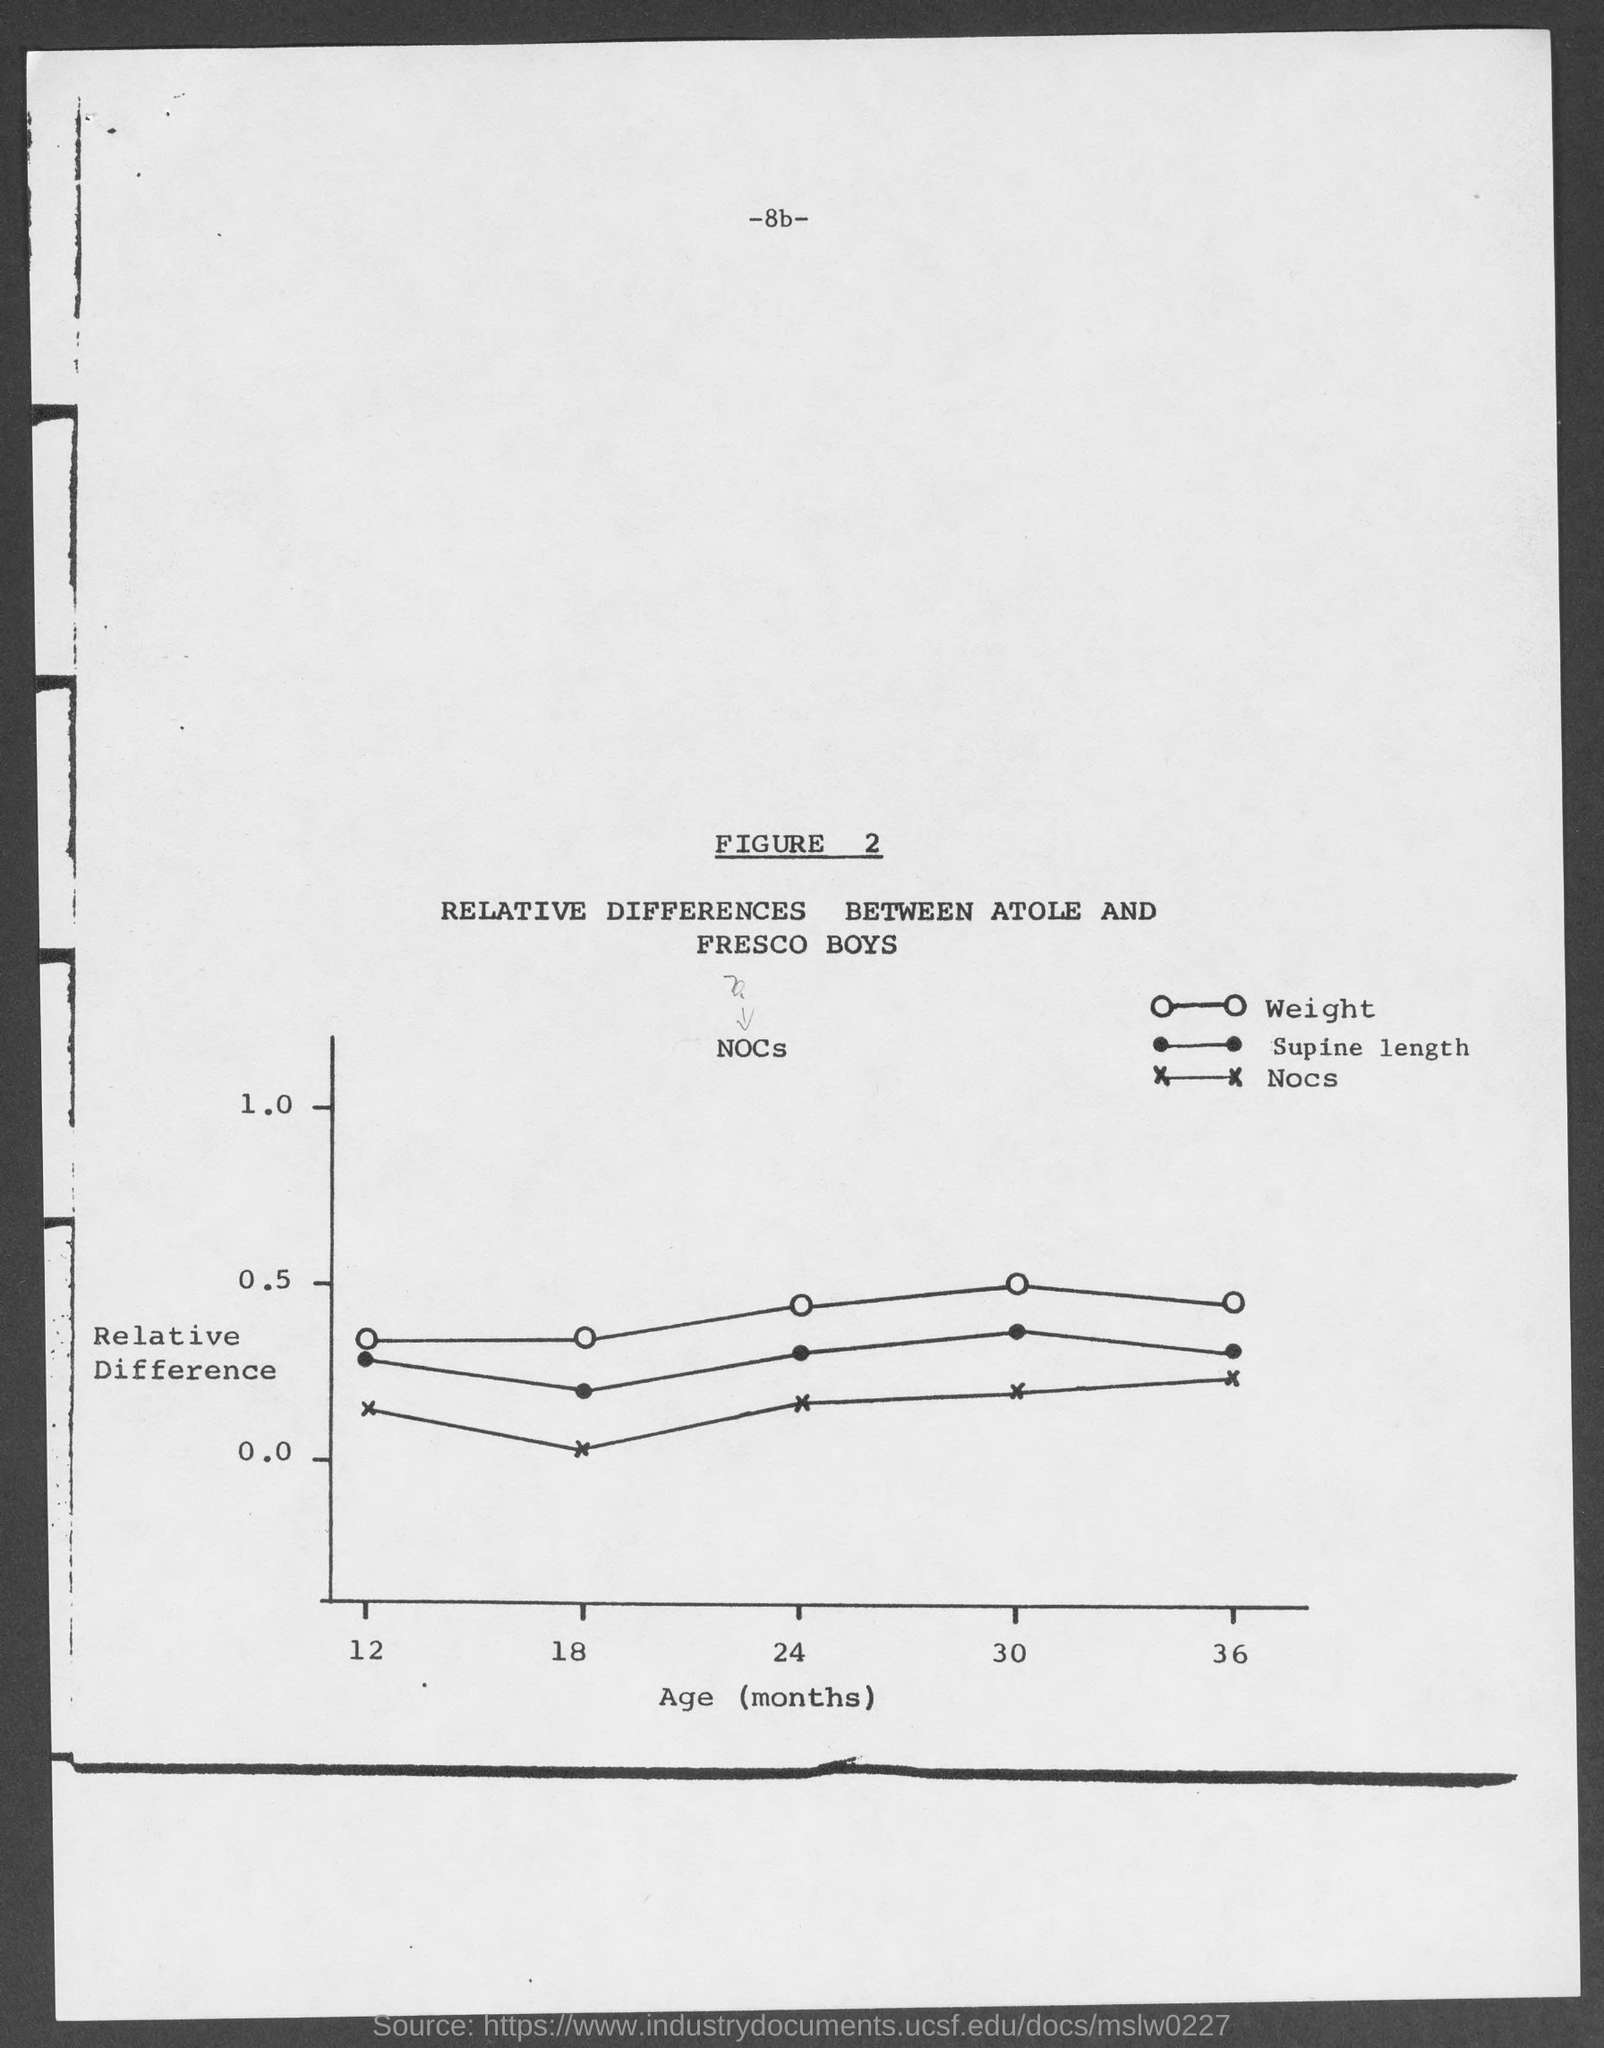What does Figure 2 represent?
Your answer should be very brief. Relative Differences Between Atole and Fresco Boys. What is the page no mentioned in this document?
Offer a terse response. -8b-. What does x-axis of the graph represent?
Your answer should be compact. Age (months). What does Y-axis of the graph represent?
Offer a very short reply. Relative Difference. 